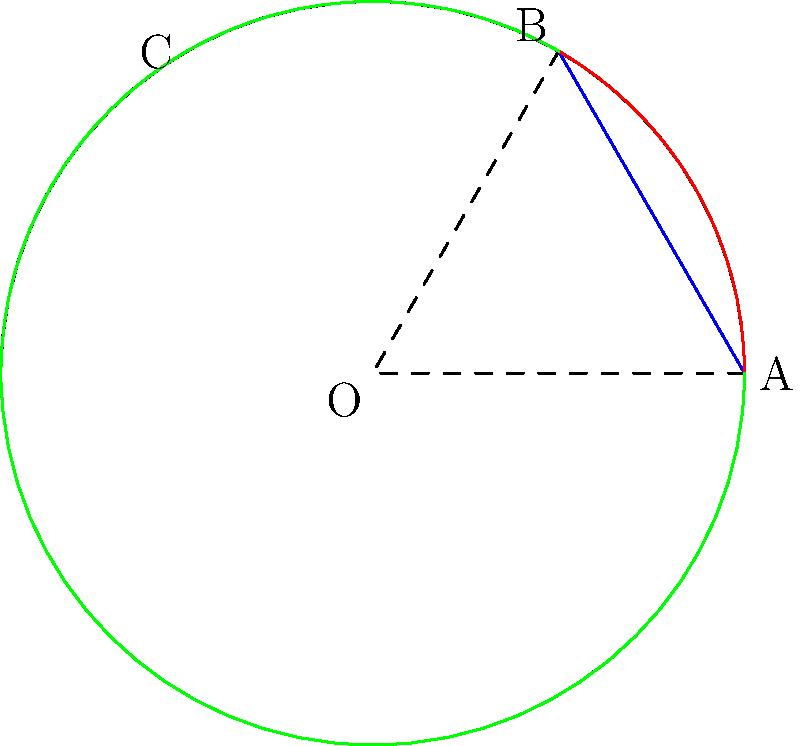As a travel influencer, you're planning content about two popular flight paths: New York to Dubai and London to Tokyo. On a globe, these paths form an angle at the center of the Earth. If the central angle for New York to Dubai is $60^\circ$ and for London to Tokyo is $120^\circ$, what is the angle between these flight paths? Let's approach this step-by-step:

1) In the diagram, arc AB represents the New York to Dubai flight path, and arc ACB represents the London to Tokyo flight path.

2) The central angle for New York to Dubai (angle AOB) is given as $60^\circ$ or $\frac{\pi}{3}$ radians.

3) The central angle for London to Tokyo (angle ACB) is given as $120^\circ$ or $\frac{2\pi}{3}$ radians.

4) The angle between the flight paths is the difference between these two central angles:

   $$\text{Angle between paths} = \text{London to Tokyo angle} - \text{New York to Dubai angle}$$

5) Substituting the values:

   $$\text{Angle between paths} = \frac{2\pi}{3} - \frac{\pi}{3} = \frac{\pi}{3}$$

6) Converting back to degrees:

   $$\frac{\pi}{3} \text{ radians} = 60^\circ$$

Therefore, the angle between the two flight paths is $60^\circ$ or $\frac{\pi}{3}$ radians.
Answer: $60^\circ$ or $\frac{\pi}{3}$ radians 